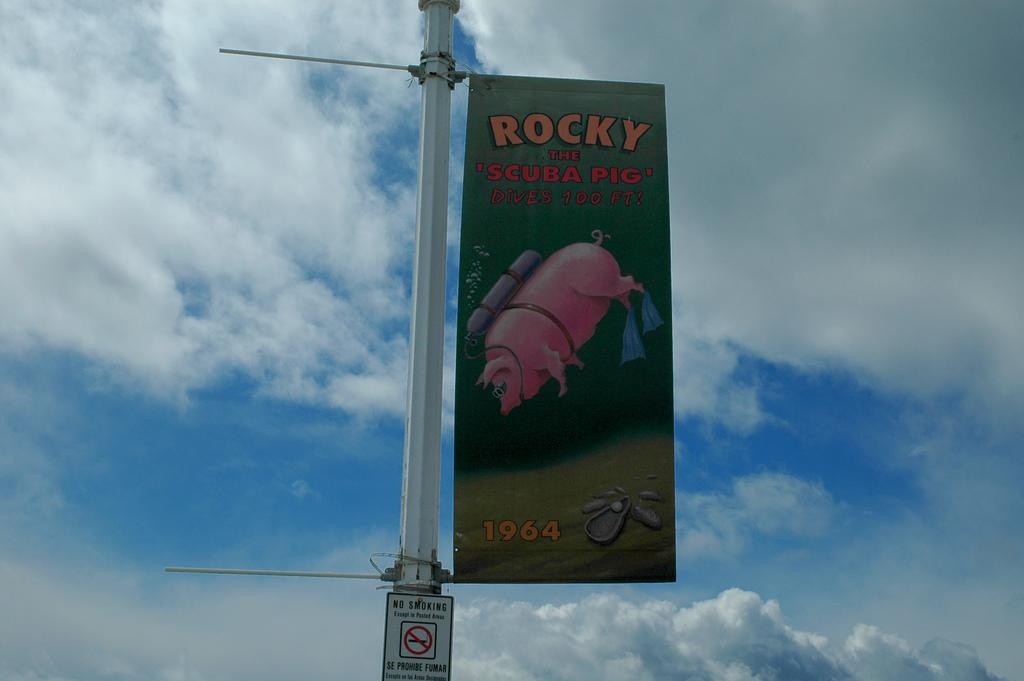<image>
Summarize the visual content of the image. A 1964 advertisement boasts a scuba diving pig. 